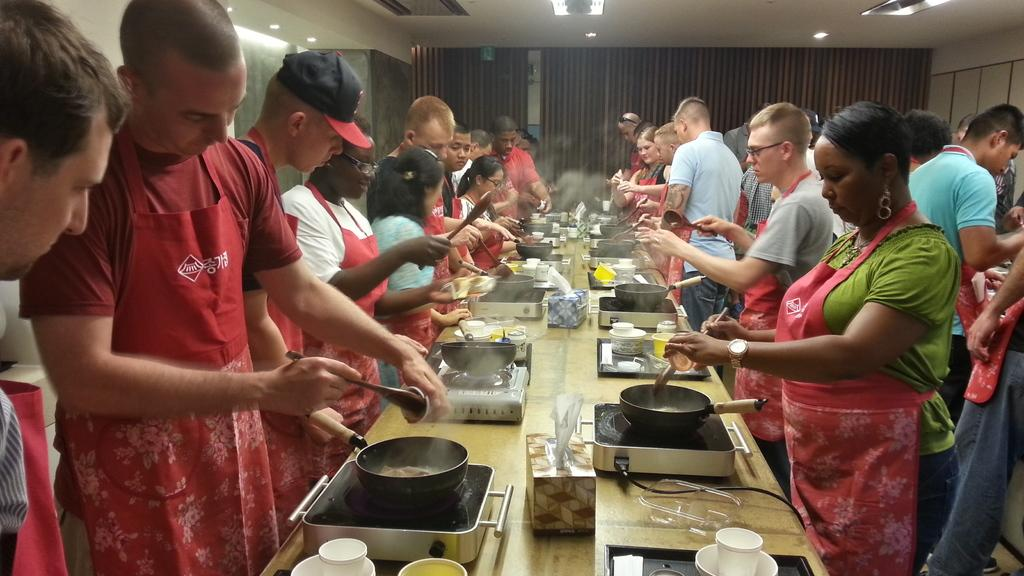How many people are in the image? There is a group of people in the image. What are the people doing in the image? The people are standing and cooking food. What appliance is used for cooking in the image? There is a stove in the image. What color is the crayon used by the people in the image? There is no crayon present in the image. How does the memory of the people in the image affect their cooking? The image does not provide information about the people's memories, so we cannot determine how their memories affect their cooking. 